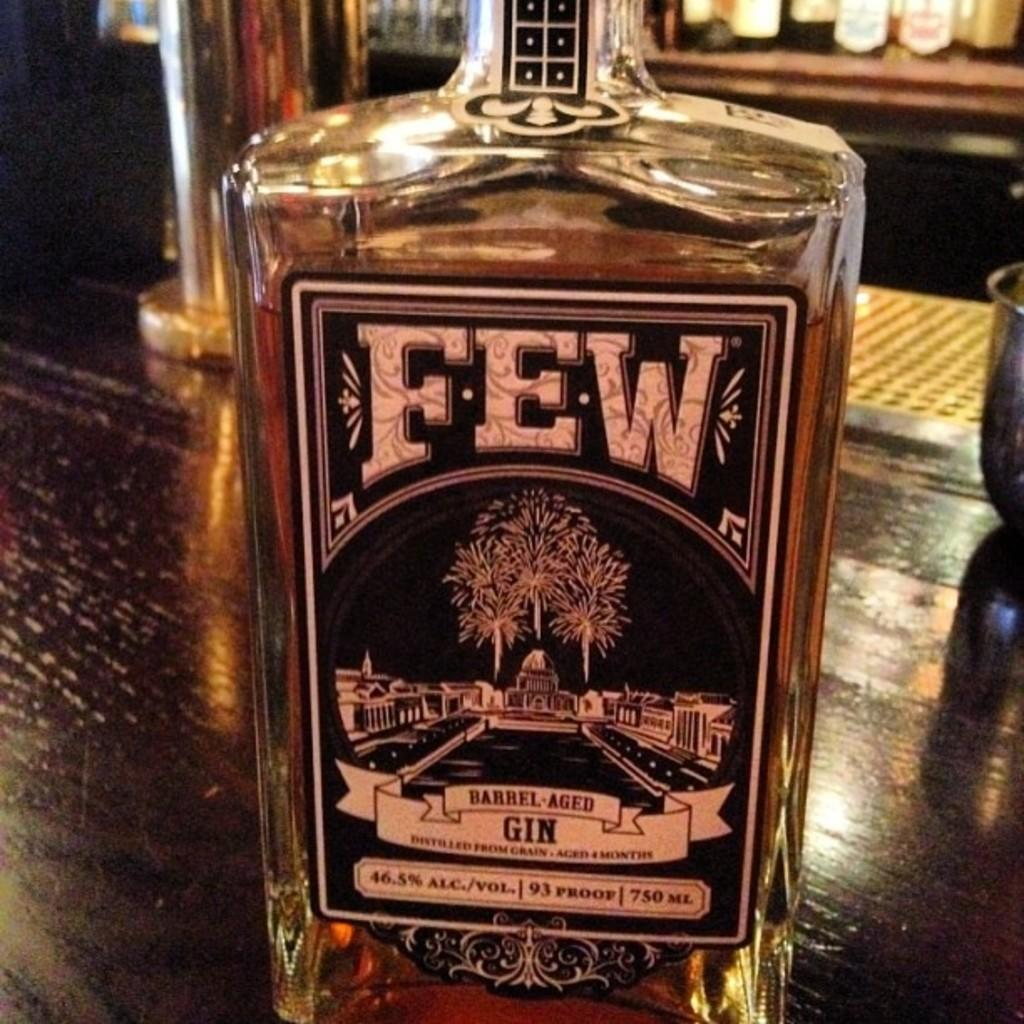Provide a one-sentence caption for the provided image. A bottle of Few Barrel Aged gin on a wooden bar counter. 